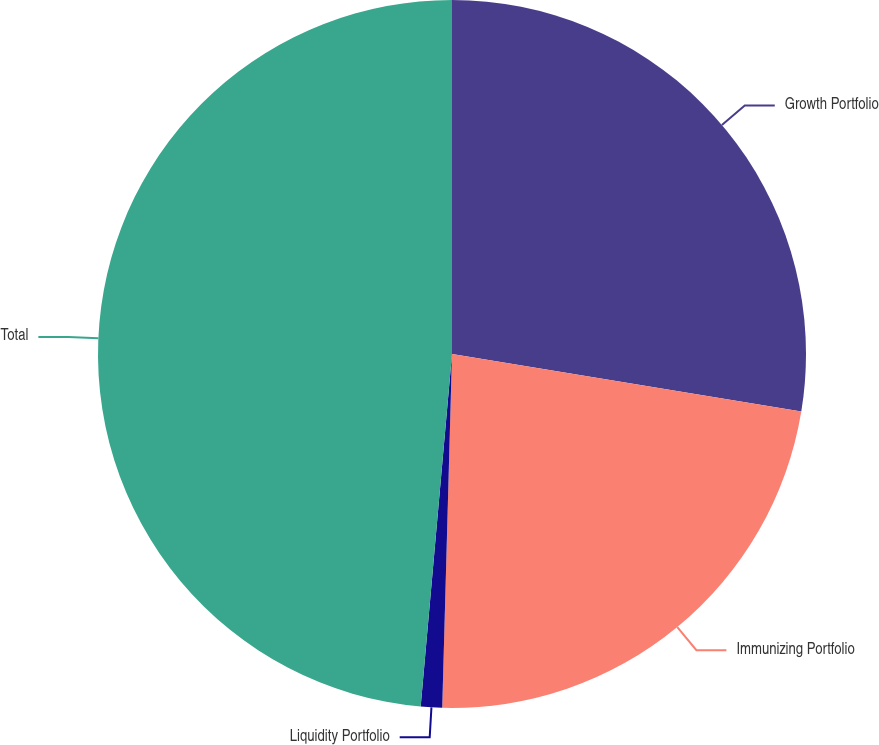Convert chart. <chart><loc_0><loc_0><loc_500><loc_500><pie_chart><fcel>Growth Portfolio<fcel>Immunizing Portfolio<fcel>Liquidity Portfolio<fcel>Total<nl><fcel>27.6%<fcel>22.84%<fcel>0.97%<fcel>48.59%<nl></chart> 